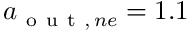<formula> <loc_0><loc_0><loc_500><loc_500>a _ { o u t , \, n e } = 1 . 1</formula> 